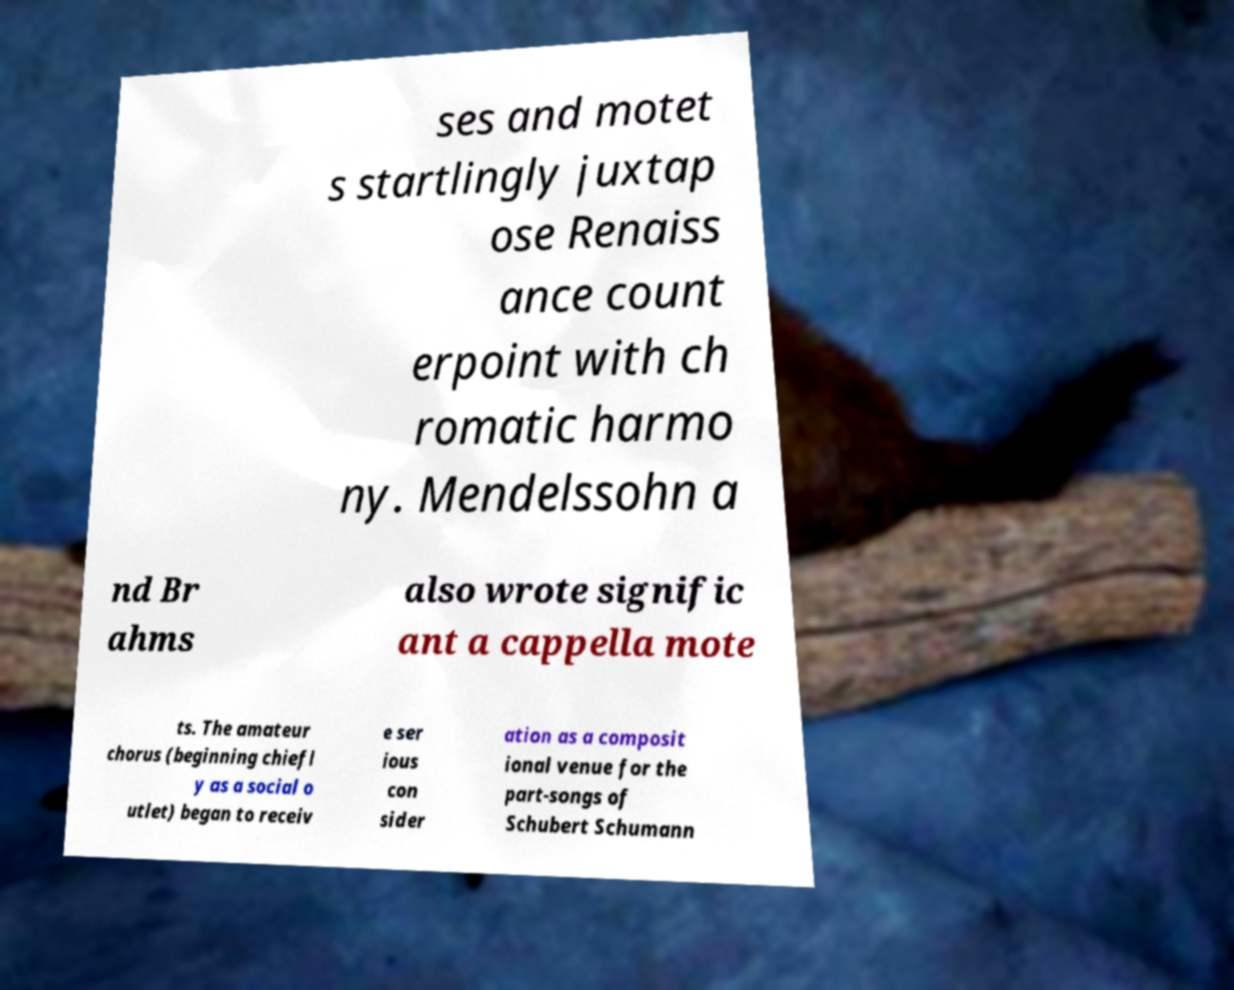Can you read and provide the text displayed in the image?This photo seems to have some interesting text. Can you extract and type it out for me? ses and motet s startlingly juxtap ose Renaiss ance count erpoint with ch romatic harmo ny. Mendelssohn a nd Br ahms also wrote signific ant a cappella mote ts. The amateur chorus (beginning chiefl y as a social o utlet) began to receiv e ser ious con sider ation as a composit ional venue for the part-songs of Schubert Schumann 